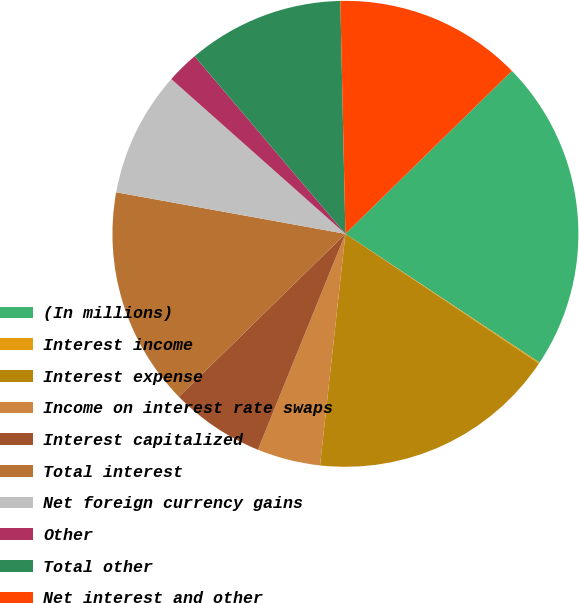<chart> <loc_0><loc_0><loc_500><loc_500><pie_chart><fcel>(In millions)<fcel>Interest income<fcel>Interest expense<fcel>Income on interest rate swaps<fcel>Interest capitalized<fcel>Total interest<fcel>Net foreign currency gains<fcel>Other<fcel>Total other<fcel>Net interest and other<nl><fcel>21.65%<fcel>0.08%<fcel>17.34%<fcel>4.39%<fcel>6.55%<fcel>15.18%<fcel>8.71%<fcel>2.23%<fcel>10.86%<fcel>13.02%<nl></chart> 